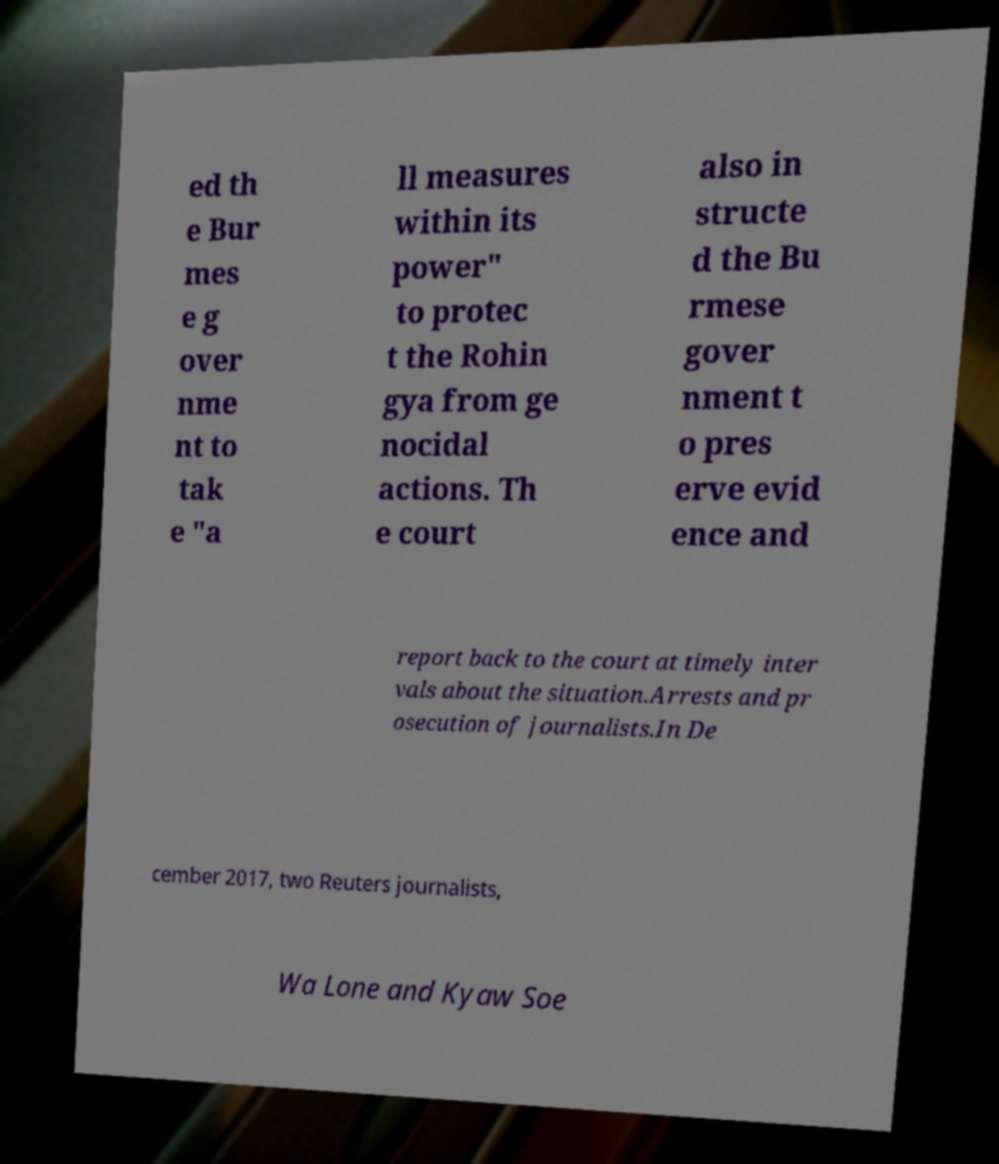Please identify and transcribe the text found in this image. ed th e Bur mes e g over nme nt to tak e "a ll measures within its power" to protec t the Rohin gya from ge nocidal actions. Th e court also in structe d the Bu rmese gover nment t o pres erve evid ence and report back to the court at timely inter vals about the situation.Arrests and pr osecution of journalists.In De cember 2017, two Reuters journalists, Wa Lone and Kyaw Soe 